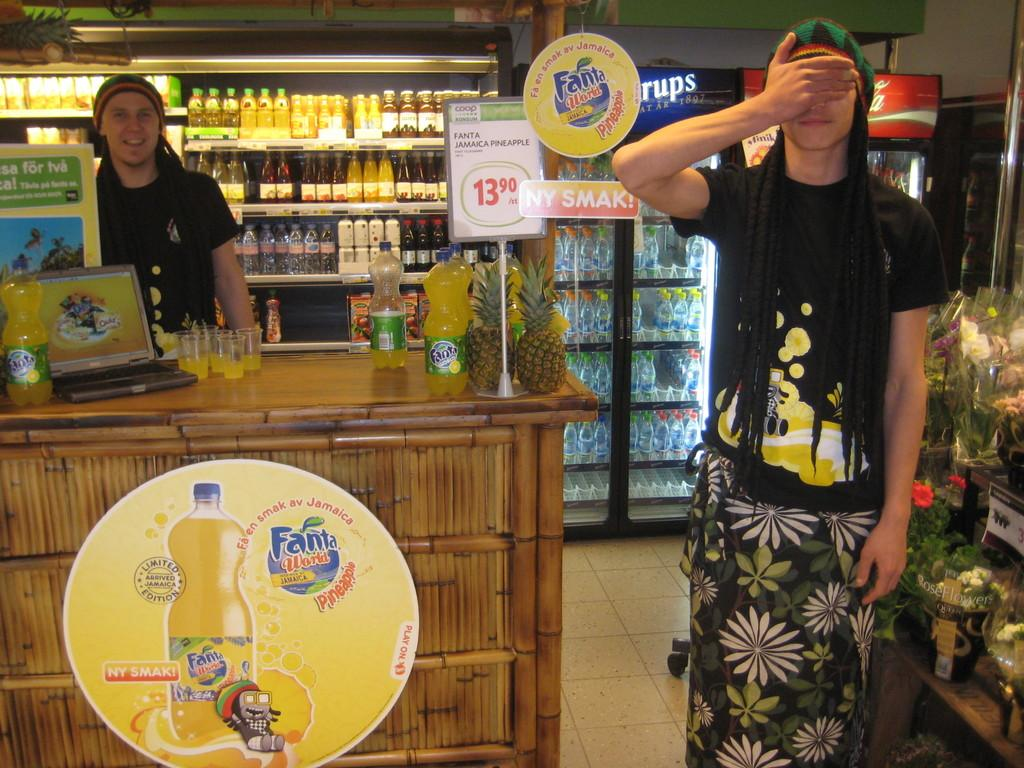<image>
Create a compact narrative representing the image presented. Signs in a beverage store advertise Fanta drinks. 